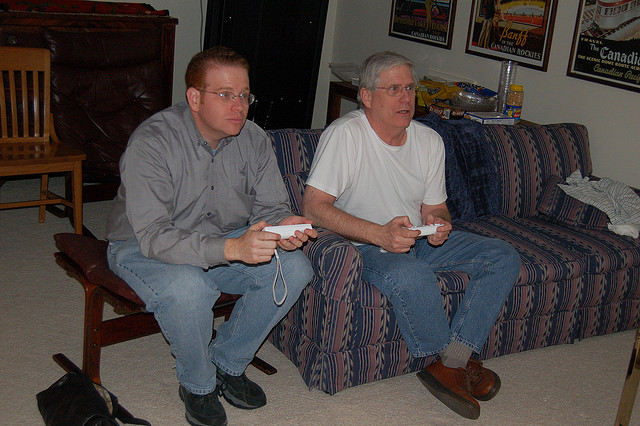<image>Where is the man's luggage? It is unknown where the man's luggage is. It could be in the closet, on the ground, behind the sofa, or in the bedroom. Where is the man's luggage? It is not clear where the man's luggage is. It can be seen in the closet, behind the sofa or next to the chair. 